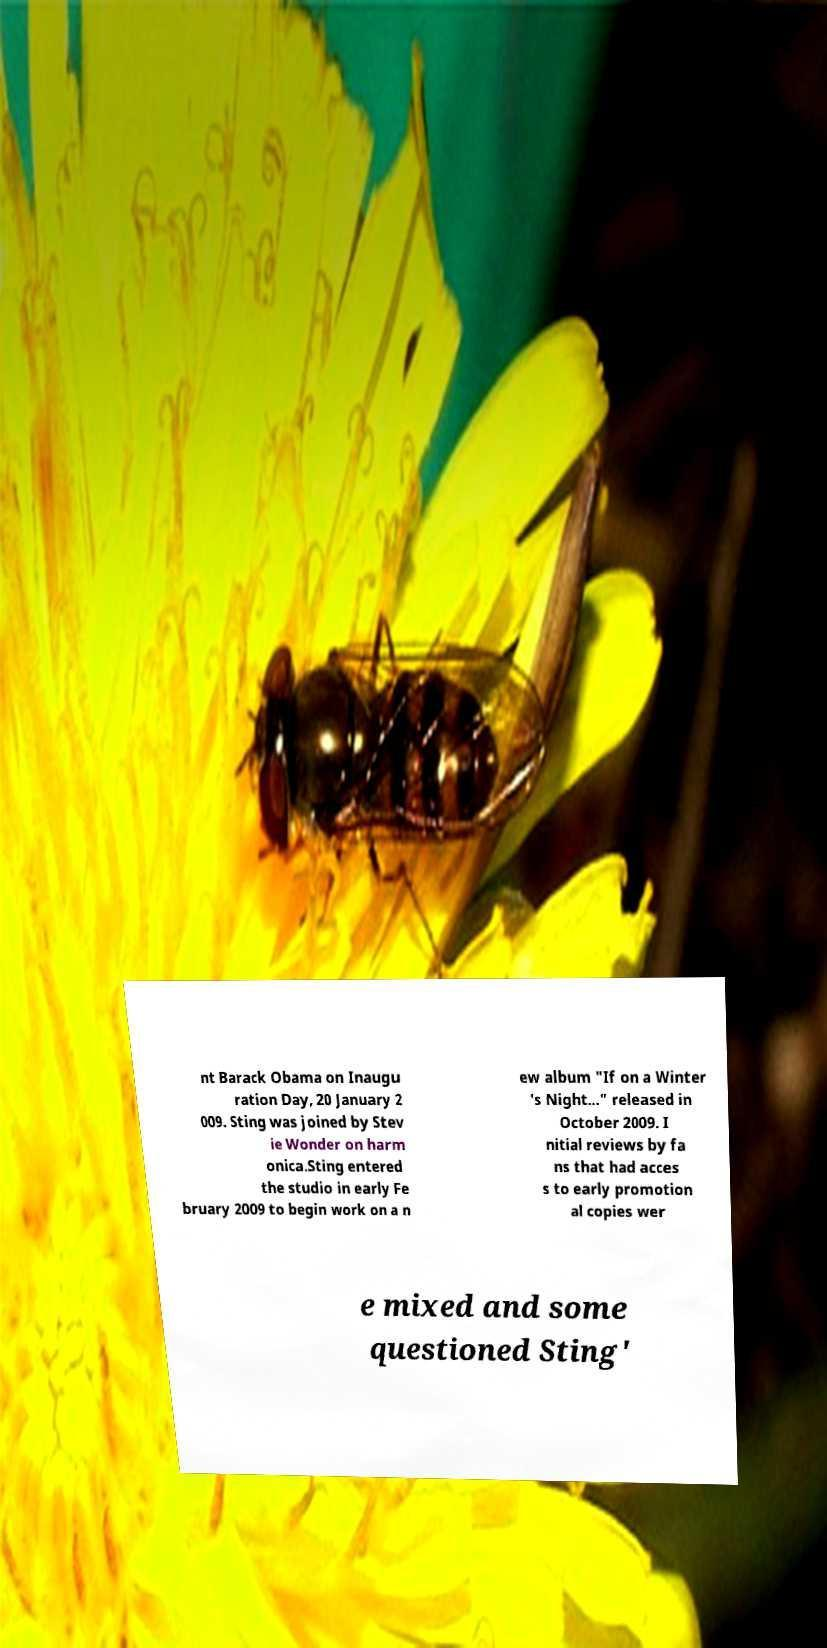Can you read and provide the text displayed in the image?This photo seems to have some interesting text. Can you extract and type it out for me? nt Barack Obama on Inaugu ration Day, 20 January 2 009. Sting was joined by Stev ie Wonder on harm onica.Sting entered the studio in early Fe bruary 2009 to begin work on a n ew album "If on a Winter 's Night..." released in October 2009. I nitial reviews by fa ns that had acces s to early promotion al copies wer e mixed and some questioned Sting' 